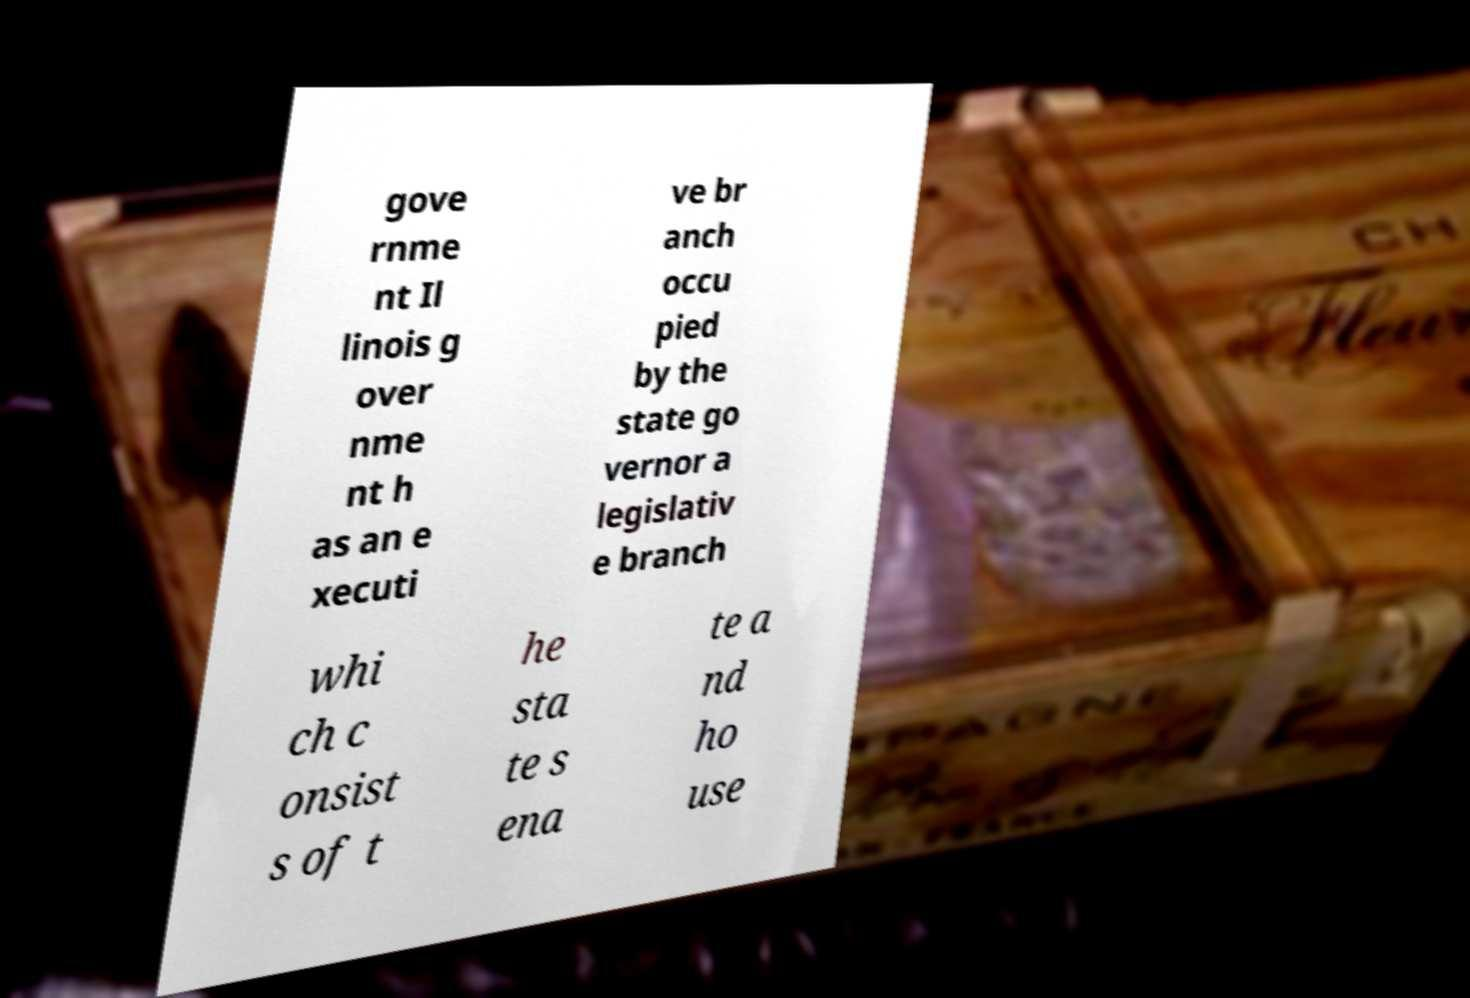There's text embedded in this image that I need extracted. Can you transcribe it verbatim? gove rnme nt Il linois g over nme nt h as an e xecuti ve br anch occu pied by the state go vernor a legislativ e branch whi ch c onsist s of t he sta te s ena te a nd ho use 